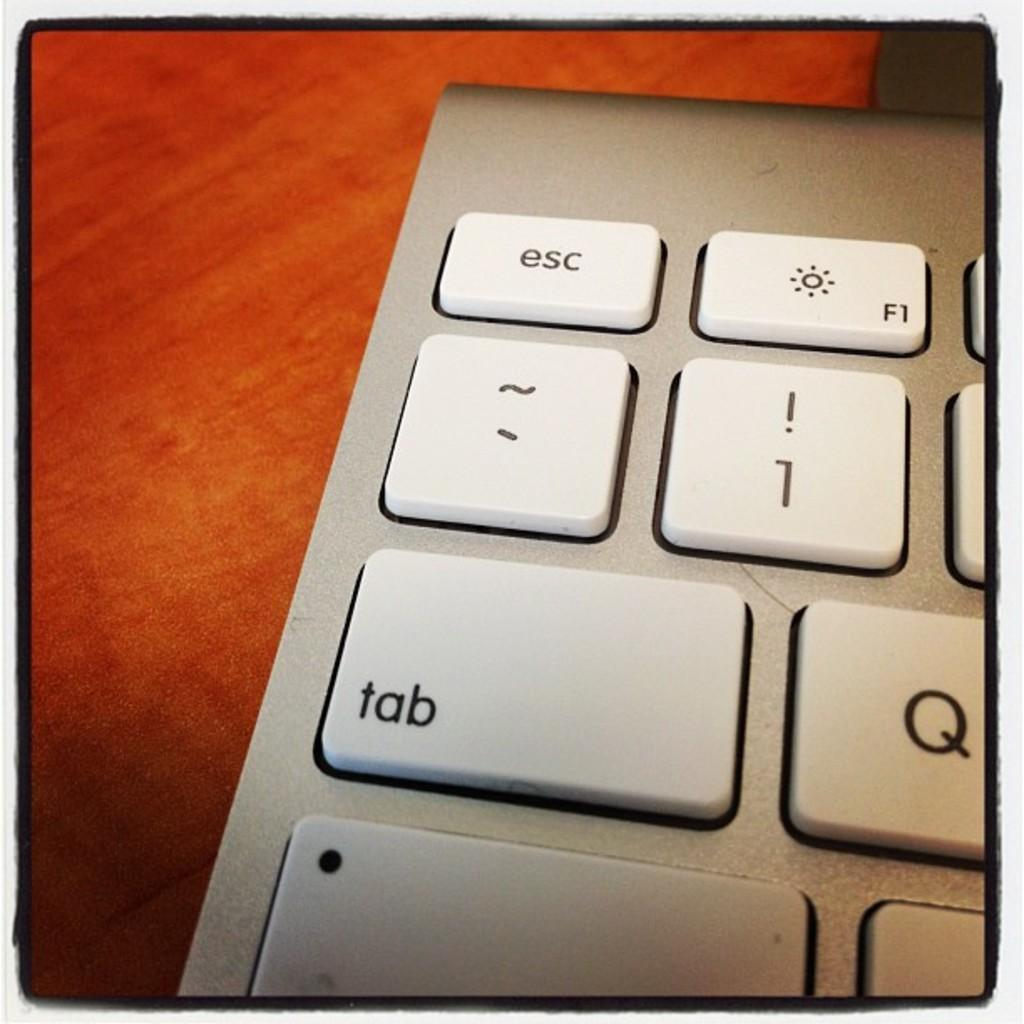<image>
Present a compact description of the photo's key features. Close up of a keyboard with the tab key prominent 